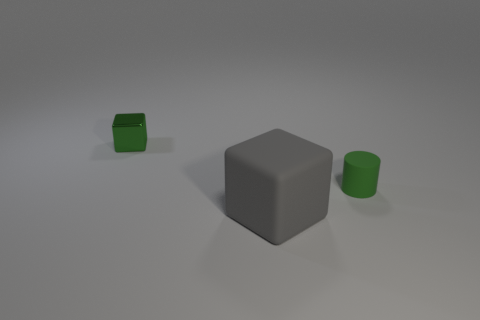From an artistic perspective, what could this arrangement symbolize? Artistically, the simple arrangement of geometric shapes might represent balance and harmony. The contrast between the circular cylinder and the square angles of the cubes could be seen as a visual metaphor for the juxtaposition of different ideas or elements. The clear-cut shapes and muted colors may also suggest themes of minimalism and the essential nature of form in art. 